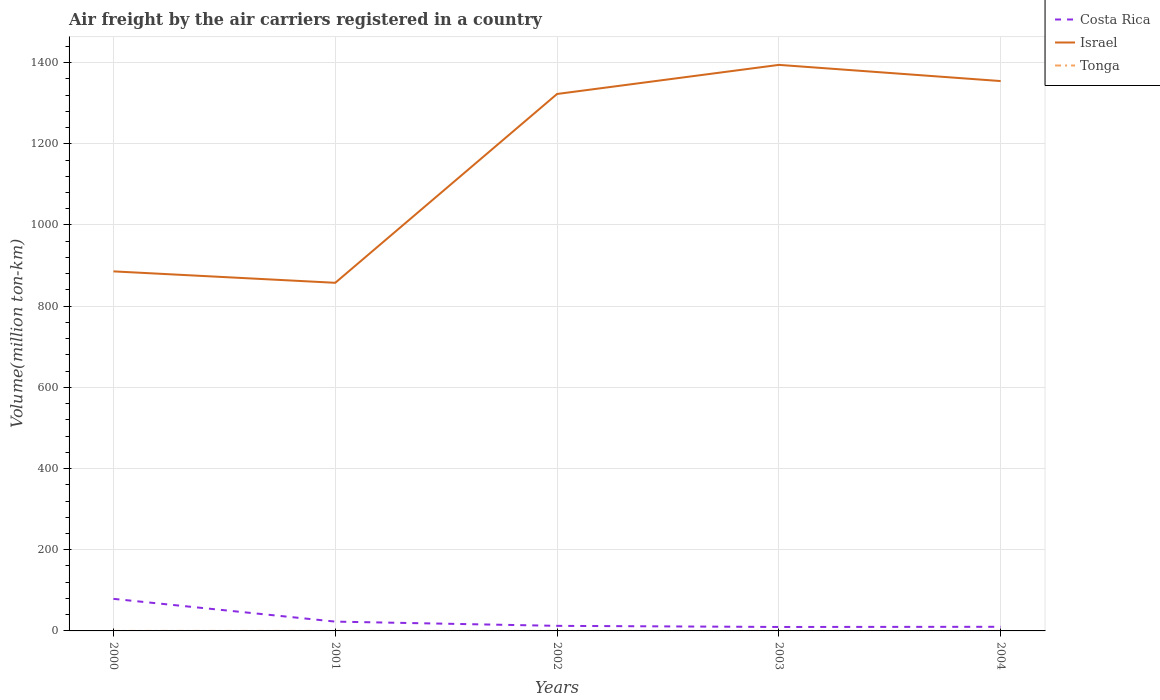How many different coloured lines are there?
Offer a very short reply. 3. Across all years, what is the maximum volume of the air carriers in Israel?
Give a very brief answer. 857.56. In which year was the volume of the air carriers in Tonga maximum?
Keep it short and to the point. 2000. What is the total volume of the air carriers in Israel in the graph?
Give a very brief answer. -508.69. What is the difference between the highest and the second highest volume of the air carriers in Costa Rica?
Give a very brief answer. 69.27. What is the difference between the highest and the lowest volume of the air carriers in Costa Rica?
Offer a very short reply. 1. How many lines are there?
Make the answer very short. 3. What is the difference between two consecutive major ticks on the Y-axis?
Provide a short and direct response. 200. Are the values on the major ticks of Y-axis written in scientific E-notation?
Offer a very short reply. No. Does the graph contain grids?
Provide a succinct answer. Yes. How many legend labels are there?
Give a very brief answer. 3. How are the legend labels stacked?
Make the answer very short. Vertical. What is the title of the graph?
Make the answer very short. Air freight by the air carriers registered in a country. Does "Puerto Rico" appear as one of the legend labels in the graph?
Keep it short and to the point. No. What is the label or title of the X-axis?
Provide a succinct answer. Years. What is the label or title of the Y-axis?
Offer a very short reply. Volume(million ton-km). What is the Volume(million ton-km) in Costa Rica in 2000?
Provide a short and direct response. 79. What is the Volume(million ton-km) of Israel in 2000?
Your response must be concise. 885.7. What is the Volume(million ton-km) in Tonga in 2000?
Keep it short and to the point. 0.02. What is the Volume(million ton-km) in Costa Rica in 2001?
Keep it short and to the point. 22.95. What is the Volume(million ton-km) of Israel in 2001?
Provide a short and direct response. 857.56. What is the Volume(million ton-km) in Tonga in 2001?
Offer a terse response. 0.02. What is the Volume(million ton-km) in Costa Rica in 2002?
Your answer should be very brief. 12.51. What is the Volume(million ton-km) in Israel in 2002?
Offer a very short reply. 1322.72. What is the Volume(million ton-km) in Tonga in 2002?
Your answer should be compact. 0.02. What is the Volume(million ton-km) in Costa Rica in 2003?
Offer a very short reply. 9.73. What is the Volume(million ton-km) in Israel in 2003?
Give a very brief answer. 1394.4. What is the Volume(million ton-km) in Tonga in 2003?
Make the answer very short. 0.03. What is the Volume(million ton-km) of Costa Rica in 2004?
Give a very brief answer. 10.17. What is the Volume(million ton-km) of Israel in 2004?
Offer a terse response. 1354.54. Across all years, what is the maximum Volume(million ton-km) in Costa Rica?
Your answer should be compact. 79. Across all years, what is the maximum Volume(million ton-km) of Israel?
Make the answer very short. 1394.4. Across all years, what is the minimum Volume(million ton-km) in Costa Rica?
Your response must be concise. 9.73. Across all years, what is the minimum Volume(million ton-km) of Israel?
Make the answer very short. 857.56. Across all years, what is the minimum Volume(million ton-km) of Tonga?
Ensure brevity in your answer.  0.02. What is the total Volume(million ton-km) in Costa Rica in the graph?
Your response must be concise. 134.37. What is the total Volume(million ton-km) in Israel in the graph?
Offer a very short reply. 5814.92. What is the total Volume(million ton-km) of Tonga in the graph?
Keep it short and to the point. 0.12. What is the difference between the Volume(million ton-km) in Costa Rica in 2000 and that in 2001?
Ensure brevity in your answer.  56.06. What is the difference between the Volume(million ton-km) in Israel in 2000 and that in 2001?
Offer a very short reply. 28.14. What is the difference between the Volume(million ton-km) in Tonga in 2000 and that in 2001?
Provide a succinct answer. -0. What is the difference between the Volume(million ton-km) in Costa Rica in 2000 and that in 2002?
Give a very brief answer. 66.5. What is the difference between the Volume(million ton-km) in Israel in 2000 and that in 2002?
Make the answer very short. -437.01. What is the difference between the Volume(million ton-km) of Tonga in 2000 and that in 2002?
Keep it short and to the point. -0.01. What is the difference between the Volume(million ton-km) in Costa Rica in 2000 and that in 2003?
Give a very brief answer. 69.27. What is the difference between the Volume(million ton-km) in Israel in 2000 and that in 2003?
Your answer should be very brief. -508.69. What is the difference between the Volume(million ton-km) of Tonga in 2000 and that in 2003?
Give a very brief answer. -0.01. What is the difference between the Volume(million ton-km) of Costa Rica in 2000 and that in 2004?
Your answer should be very brief. 68.83. What is the difference between the Volume(million ton-km) in Israel in 2000 and that in 2004?
Your answer should be compact. -468.83. What is the difference between the Volume(million ton-km) in Tonga in 2000 and that in 2004?
Give a very brief answer. -0.01. What is the difference between the Volume(million ton-km) in Costa Rica in 2001 and that in 2002?
Offer a very short reply. 10.44. What is the difference between the Volume(million ton-km) in Israel in 2001 and that in 2002?
Offer a very short reply. -465.16. What is the difference between the Volume(million ton-km) in Tonga in 2001 and that in 2002?
Keep it short and to the point. -0. What is the difference between the Volume(million ton-km) of Costa Rica in 2001 and that in 2003?
Give a very brief answer. 13.21. What is the difference between the Volume(million ton-km) in Israel in 2001 and that in 2003?
Make the answer very short. -536.84. What is the difference between the Volume(million ton-km) in Tonga in 2001 and that in 2003?
Offer a very short reply. -0. What is the difference between the Volume(million ton-km) in Costa Rica in 2001 and that in 2004?
Your answer should be very brief. 12.78. What is the difference between the Volume(million ton-km) in Israel in 2001 and that in 2004?
Your answer should be compact. -496.98. What is the difference between the Volume(million ton-km) of Tonga in 2001 and that in 2004?
Provide a succinct answer. -0.01. What is the difference between the Volume(million ton-km) of Costa Rica in 2002 and that in 2003?
Your answer should be compact. 2.77. What is the difference between the Volume(million ton-km) in Israel in 2002 and that in 2003?
Your answer should be compact. -71.68. What is the difference between the Volume(million ton-km) in Tonga in 2002 and that in 2003?
Make the answer very short. -0. What is the difference between the Volume(million ton-km) in Costa Rica in 2002 and that in 2004?
Your response must be concise. 2.33. What is the difference between the Volume(million ton-km) in Israel in 2002 and that in 2004?
Make the answer very short. -31.82. What is the difference between the Volume(million ton-km) of Tonga in 2002 and that in 2004?
Give a very brief answer. -0.01. What is the difference between the Volume(million ton-km) of Costa Rica in 2003 and that in 2004?
Make the answer very short. -0.44. What is the difference between the Volume(million ton-km) of Israel in 2003 and that in 2004?
Offer a very short reply. 39.86. What is the difference between the Volume(million ton-km) of Tonga in 2003 and that in 2004?
Provide a succinct answer. -0.01. What is the difference between the Volume(million ton-km) in Costa Rica in 2000 and the Volume(million ton-km) in Israel in 2001?
Your response must be concise. -778.56. What is the difference between the Volume(million ton-km) in Costa Rica in 2000 and the Volume(million ton-km) in Tonga in 2001?
Ensure brevity in your answer.  78.98. What is the difference between the Volume(million ton-km) of Israel in 2000 and the Volume(million ton-km) of Tonga in 2001?
Your answer should be very brief. 885.68. What is the difference between the Volume(million ton-km) in Costa Rica in 2000 and the Volume(million ton-km) in Israel in 2002?
Give a very brief answer. -1243.71. What is the difference between the Volume(million ton-km) of Costa Rica in 2000 and the Volume(million ton-km) of Tonga in 2002?
Keep it short and to the point. 78.98. What is the difference between the Volume(million ton-km) of Israel in 2000 and the Volume(million ton-km) of Tonga in 2002?
Make the answer very short. 885.68. What is the difference between the Volume(million ton-km) in Costa Rica in 2000 and the Volume(million ton-km) in Israel in 2003?
Your response must be concise. -1315.39. What is the difference between the Volume(million ton-km) of Costa Rica in 2000 and the Volume(million ton-km) of Tonga in 2003?
Provide a short and direct response. 78.98. What is the difference between the Volume(million ton-km) of Israel in 2000 and the Volume(million ton-km) of Tonga in 2003?
Provide a short and direct response. 885.68. What is the difference between the Volume(million ton-km) of Costa Rica in 2000 and the Volume(million ton-km) of Israel in 2004?
Your answer should be compact. -1275.53. What is the difference between the Volume(million ton-km) in Costa Rica in 2000 and the Volume(million ton-km) in Tonga in 2004?
Your response must be concise. 78.97. What is the difference between the Volume(million ton-km) of Israel in 2000 and the Volume(million ton-km) of Tonga in 2004?
Your response must be concise. 885.67. What is the difference between the Volume(million ton-km) in Costa Rica in 2001 and the Volume(million ton-km) in Israel in 2002?
Provide a succinct answer. -1299.77. What is the difference between the Volume(million ton-km) of Costa Rica in 2001 and the Volume(million ton-km) of Tonga in 2002?
Your answer should be compact. 22.92. What is the difference between the Volume(million ton-km) of Israel in 2001 and the Volume(million ton-km) of Tonga in 2002?
Your response must be concise. 857.54. What is the difference between the Volume(million ton-km) of Costa Rica in 2001 and the Volume(million ton-km) of Israel in 2003?
Provide a succinct answer. -1371.45. What is the difference between the Volume(million ton-km) of Costa Rica in 2001 and the Volume(million ton-km) of Tonga in 2003?
Provide a succinct answer. 22.92. What is the difference between the Volume(million ton-km) in Israel in 2001 and the Volume(million ton-km) in Tonga in 2003?
Offer a very short reply. 857.54. What is the difference between the Volume(million ton-km) of Costa Rica in 2001 and the Volume(million ton-km) of Israel in 2004?
Your answer should be compact. -1331.59. What is the difference between the Volume(million ton-km) in Costa Rica in 2001 and the Volume(million ton-km) in Tonga in 2004?
Provide a succinct answer. 22.92. What is the difference between the Volume(million ton-km) in Israel in 2001 and the Volume(million ton-km) in Tonga in 2004?
Provide a short and direct response. 857.53. What is the difference between the Volume(million ton-km) of Costa Rica in 2002 and the Volume(million ton-km) of Israel in 2003?
Provide a short and direct response. -1381.89. What is the difference between the Volume(million ton-km) of Costa Rica in 2002 and the Volume(million ton-km) of Tonga in 2003?
Your response must be concise. 12.48. What is the difference between the Volume(million ton-km) in Israel in 2002 and the Volume(million ton-km) in Tonga in 2003?
Provide a short and direct response. 1322.69. What is the difference between the Volume(million ton-km) of Costa Rica in 2002 and the Volume(million ton-km) of Israel in 2004?
Offer a terse response. -1342.03. What is the difference between the Volume(million ton-km) of Costa Rica in 2002 and the Volume(million ton-km) of Tonga in 2004?
Give a very brief answer. 12.48. What is the difference between the Volume(million ton-km) of Israel in 2002 and the Volume(million ton-km) of Tonga in 2004?
Make the answer very short. 1322.69. What is the difference between the Volume(million ton-km) in Costa Rica in 2003 and the Volume(million ton-km) in Israel in 2004?
Ensure brevity in your answer.  -1344.8. What is the difference between the Volume(million ton-km) of Costa Rica in 2003 and the Volume(million ton-km) of Tonga in 2004?
Make the answer very short. 9.71. What is the difference between the Volume(million ton-km) in Israel in 2003 and the Volume(million ton-km) in Tonga in 2004?
Your answer should be very brief. 1394.37. What is the average Volume(million ton-km) in Costa Rica per year?
Offer a terse response. 26.87. What is the average Volume(million ton-km) in Israel per year?
Provide a succinct answer. 1162.98. What is the average Volume(million ton-km) of Tonga per year?
Your answer should be compact. 0.02. In the year 2000, what is the difference between the Volume(million ton-km) of Costa Rica and Volume(million ton-km) of Israel?
Ensure brevity in your answer.  -806.7. In the year 2000, what is the difference between the Volume(million ton-km) in Costa Rica and Volume(million ton-km) in Tonga?
Offer a very short reply. 78.99. In the year 2000, what is the difference between the Volume(million ton-km) of Israel and Volume(million ton-km) of Tonga?
Keep it short and to the point. 885.69. In the year 2001, what is the difference between the Volume(million ton-km) of Costa Rica and Volume(million ton-km) of Israel?
Your response must be concise. -834.61. In the year 2001, what is the difference between the Volume(million ton-km) of Costa Rica and Volume(million ton-km) of Tonga?
Your response must be concise. 22.93. In the year 2001, what is the difference between the Volume(million ton-km) of Israel and Volume(million ton-km) of Tonga?
Make the answer very short. 857.54. In the year 2002, what is the difference between the Volume(million ton-km) of Costa Rica and Volume(million ton-km) of Israel?
Give a very brief answer. -1310.21. In the year 2002, what is the difference between the Volume(million ton-km) of Costa Rica and Volume(million ton-km) of Tonga?
Offer a very short reply. 12.48. In the year 2002, what is the difference between the Volume(million ton-km) in Israel and Volume(million ton-km) in Tonga?
Make the answer very short. 1322.69. In the year 2003, what is the difference between the Volume(million ton-km) of Costa Rica and Volume(million ton-km) of Israel?
Your answer should be very brief. -1384.66. In the year 2003, what is the difference between the Volume(million ton-km) in Costa Rica and Volume(million ton-km) in Tonga?
Your answer should be very brief. 9.71. In the year 2003, what is the difference between the Volume(million ton-km) in Israel and Volume(million ton-km) in Tonga?
Keep it short and to the point. 1394.37. In the year 2004, what is the difference between the Volume(million ton-km) of Costa Rica and Volume(million ton-km) of Israel?
Ensure brevity in your answer.  -1344.36. In the year 2004, what is the difference between the Volume(million ton-km) in Costa Rica and Volume(million ton-km) in Tonga?
Your answer should be very brief. 10.14. In the year 2004, what is the difference between the Volume(million ton-km) of Israel and Volume(million ton-km) of Tonga?
Make the answer very short. 1354.51. What is the ratio of the Volume(million ton-km) of Costa Rica in 2000 to that in 2001?
Your answer should be compact. 3.44. What is the ratio of the Volume(million ton-km) of Israel in 2000 to that in 2001?
Keep it short and to the point. 1.03. What is the ratio of the Volume(million ton-km) in Tonga in 2000 to that in 2001?
Make the answer very short. 0.81. What is the ratio of the Volume(million ton-km) in Costa Rica in 2000 to that in 2002?
Provide a succinct answer. 6.32. What is the ratio of the Volume(million ton-km) of Israel in 2000 to that in 2002?
Provide a succinct answer. 0.67. What is the ratio of the Volume(million ton-km) in Tonga in 2000 to that in 2002?
Make the answer very short. 0.71. What is the ratio of the Volume(million ton-km) of Costa Rica in 2000 to that in 2003?
Ensure brevity in your answer.  8.12. What is the ratio of the Volume(million ton-km) in Israel in 2000 to that in 2003?
Offer a very short reply. 0.64. What is the ratio of the Volume(million ton-km) of Tonga in 2000 to that in 2003?
Your answer should be compact. 0.68. What is the ratio of the Volume(million ton-km) of Costa Rica in 2000 to that in 2004?
Provide a succinct answer. 7.77. What is the ratio of the Volume(million ton-km) in Israel in 2000 to that in 2004?
Give a very brief answer. 0.65. What is the ratio of the Volume(million ton-km) in Tonga in 2000 to that in 2004?
Ensure brevity in your answer.  0.57. What is the ratio of the Volume(million ton-km) of Costa Rica in 2001 to that in 2002?
Ensure brevity in your answer.  1.83. What is the ratio of the Volume(million ton-km) of Israel in 2001 to that in 2002?
Make the answer very short. 0.65. What is the ratio of the Volume(million ton-km) in Costa Rica in 2001 to that in 2003?
Provide a succinct answer. 2.36. What is the ratio of the Volume(million ton-km) in Israel in 2001 to that in 2003?
Provide a short and direct response. 0.61. What is the ratio of the Volume(million ton-km) in Tonga in 2001 to that in 2003?
Make the answer very short. 0.84. What is the ratio of the Volume(million ton-km) of Costa Rica in 2001 to that in 2004?
Your answer should be very brief. 2.26. What is the ratio of the Volume(million ton-km) of Israel in 2001 to that in 2004?
Give a very brief answer. 0.63. What is the ratio of the Volume(million ton-km) of Costa Rica in 2002 to that in 2003?
Provide a short and direct response. 1.28. What is the ratio of the Volume(million ton-km) of Israel in 2002 to that in 2003?
Provide a succinct answer. 0.95. What is the ratio of the Volume(million ton-km) in Costa Rica in 2002 to that in 2004?
Your answer should be very brief. 1.23. What is the ratio of the Volume(million ton-km) of Israel in 2002 to that in 2004?
Make the answer very short. 0.98. What is the ratio of the Volume(million ton-km) in Costa Rica in 2003 to that in 2004?
Ensure brevity in your answer.  0.96. What is the ratio of the Volume(million ton-km) in Israel in 2003 to that in 2004?
Your response must be concise. 1.03. What is the difference between the highest and the second highest Volume(million ton-km) of Costa Rica?
Provide a succinct answer. 56.06. What is the difference between the highest and the second highest Volume(million ton-km) in Israel?
Keep it short and to the point. 39.86. What is the difference between the highest and the second highest Volume(million ton-km) in Tonga?
Offer a very short reply. 0.01. What is the difference between the highest and the lowest Volume(million ton-km) in Costa Rica?
Keep it short and to the point. 69.27. What is the difference between the highest and the lowest Volume(million ton-km) in Israel?
Ensure brevity in your answer.  536.84. What is the difference between the highest and the lowest Volume(million ton-km) of Tonga?
Offer a very short reply. 0.01. 